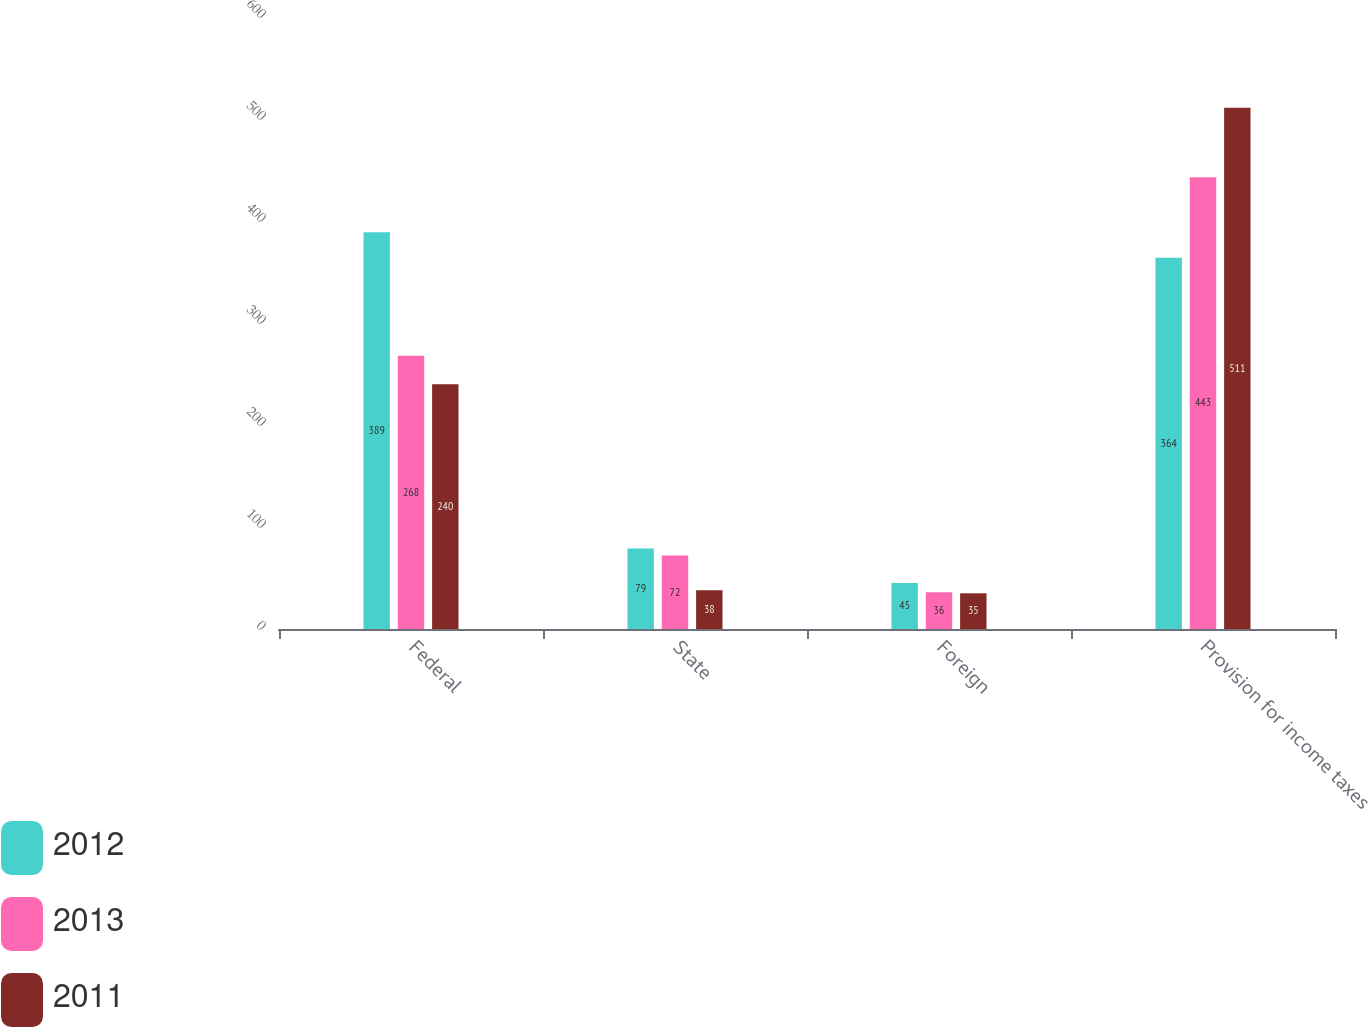Convert chart. <chart><loc_0><loc_0><loc_500><loc_500><stacked_bar_chart><ecel><fcel>Federal<fcel>State<fcel>Foreign<fcel>Provision for income taxes<nl><fcel>2012<fcel>389<fcel>79<fcel>45<fcel>364<nl><fcel>2013<fcel>268<fcel>72<fcel>36<fcel>443<nl><fcel>2011<fcel>240<fcel>38<fcel>35<fcel>511<nl></chart> 